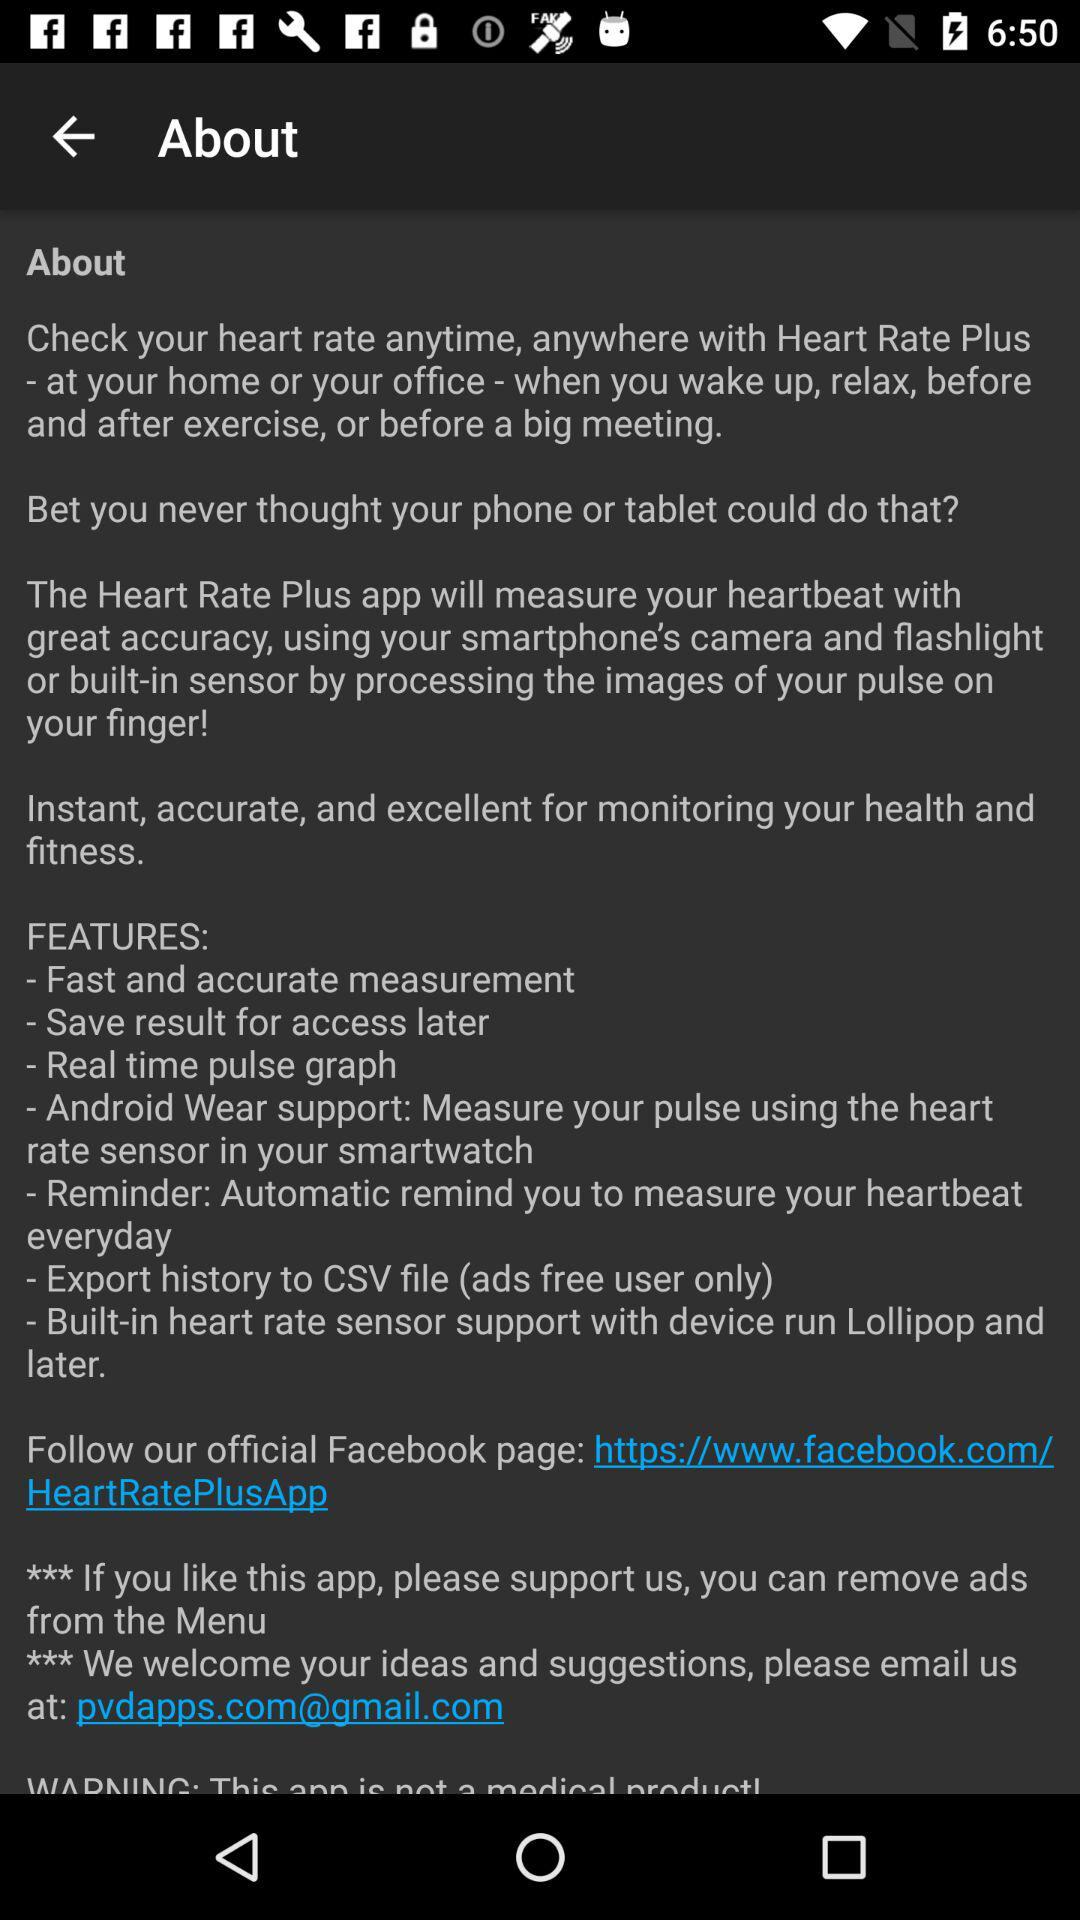What are the features of the Heart Rate Plus application? The features are: "Fast and accurate measurement", "Save result for access later", "Real time pulse graph", "Android Wear support: Measure your pulse using the heart rate sensor in your smartwatch", "Reminder: Automatic remind you to measure your heartbeat everyday", "Export history to CSV file (ads free user only)", and "Built-in heart rate sensor support with device run Lollipop and later". 